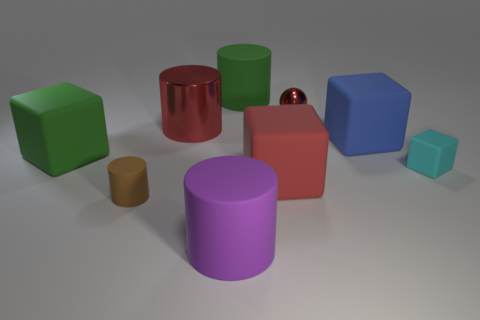How many blocks are either small yellow metal things or red rubber things?
Keep it short and to the point. 1. What number of small red balls are made of the same material as the purple thing?
Offer a terse response. 0. There is another large object that is the same color as the large metal object; what shape is it?
Ensure brevity in your answer.  Cube. What is the object that is behind the green block and to the right of the tiny metal thing made of?
Provide a short and direct response. Rubber. What shape is the green thing behind the large blue object?
Make the answer very short. Cylinder. What is the shape of the red thing that is behind the red thing that is on the left side of the red matte object?
Provide a succinct answer. Sphere. Are there any big red metallic objects that have the same shape as the brown matte object?
Provide a short and direct response. Yes. There is another rubber thing that is the same size as the brown thing; what is its shape?
Make the answer very short. Cube. There is a big red thing on the left side of the green object that is to the right of the large purple object; is there a big cube to the left of it?
Ensure brevity in your answer.  Yes. Is there a blue rubber block of the same size as the red sphere?
Your response must be concise. No. 